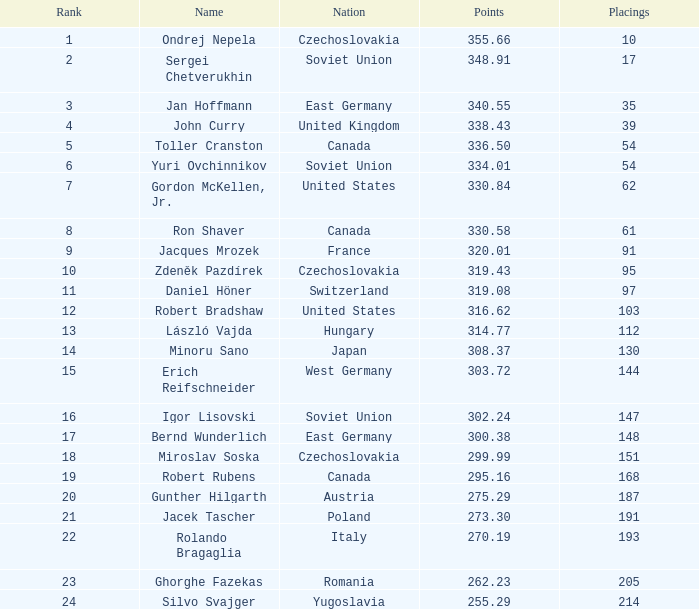43? None. 